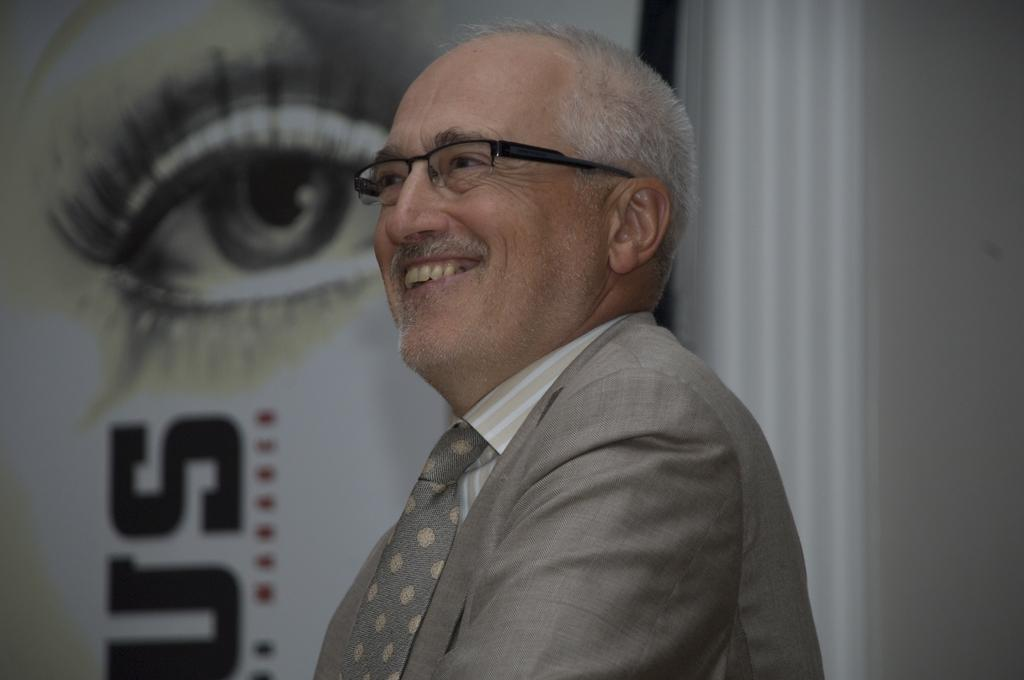Who is present in the image? There is a man in the image. What can be seen on the wall in the image? There is a picture of an eye on a wall in the image. What else is on the wall besides the picture of the eye? There is text on the wall in the image. What type of baseball equipment is visible in the image? There is no baseball equipment present in the image. What type of cover is on the judge's chair in the image? There is no judge or chair present in the image. 